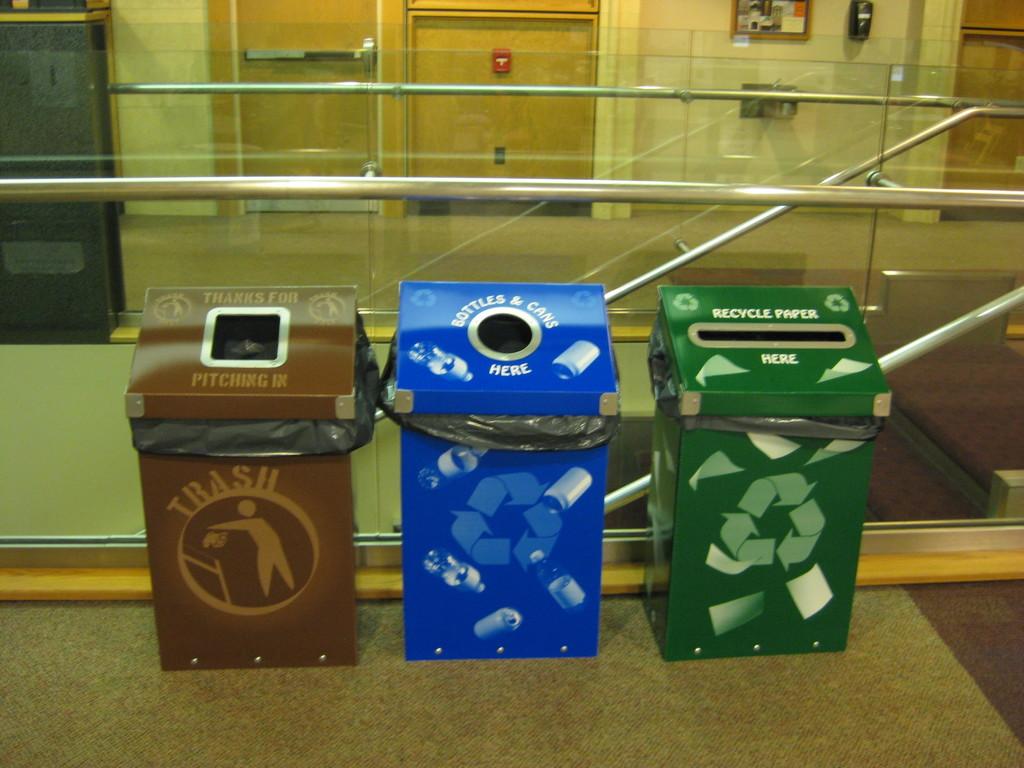What kind of bins are these?
Your response must be concise. Trash and recycling. What bin is on the left?
Offer a terse response. Trash. 